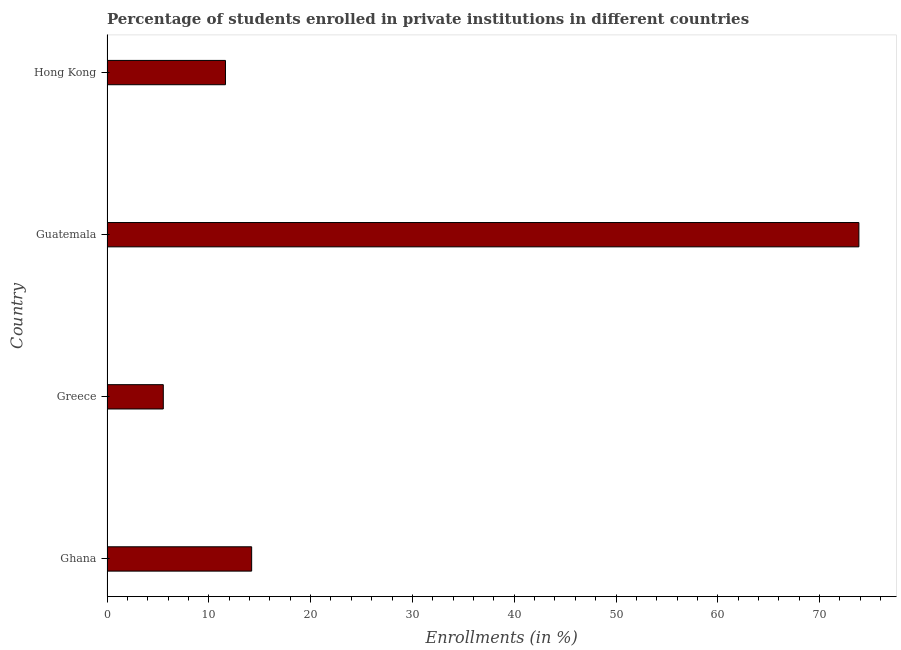Does the graph contain any zero values?
Your answer should be very brief. No. What is the title of the graph?
Your response must be concise. Percentage of students enrolled in private institutions in different countries. What is the label or title of the X-axis?
Ensure brevity in your answer.  Enrollments (in %). What is the label or title of the Y-axis?
Ensure brevity in your answer.  Country. What is the enrollments in private institutions in Greece?
Offer a terse response. 5.53. Across all countries, what is the maximum enrollments in private institutions?
Your answer should be very brief. 73.86. Across all countries, what is the minimum enrollments in private institutions?
Keep it short and to the point. 5.53. In which country was the enrollments in private institutions maximum?
Offer a very short reply. Guatemala. In which country was the enrollments in private institutions minimum?
Your answer should be very brief. Greece. What is the sum of the enrollments in private institutions?
Your answer should be compact. 105.24. What is the difference between the enrollments in private institutions in Greece and Guatemala?
Give a very brief answer. -68.33. What is the average enrollments in private institutions per country?
Keep it short and to the point. 26.31. What is the median enrollments in private institutions?
Keep it short and to the point. 12.92. In how many countries, is the enrollments in private institutions greater than 36 %?
Your answer should be very brief. 1. What is the ratio of the enrollments in private institutions in Ghana to that in Greece?
Provide a succinct answer. 2.57. What is the difference between the highest and the second highest enrollments in private institutions?
Ensure brevity in your answer.  59.65. What is the difference between the highest and the lowest enrollments in private institutions?
Provide a succinct answer. 68.33. In how many countries, is the enrollments in private institutions greater than the average enrollments in private institutions taken over all countries?
Keep it short and to the point. 1. Are all the bars in the graph horizontal?
Provide a succinct answer. Yes. Are the values on the major ticks of X-axis written in scientific E-notation?
Make the answer very short. No. What is the Enrollments (in %) of Ghana?
Offer a very short reply. 14.21. What is the Enrollments (in %) in Greece?
Offer a terse response. 5.53. What is the Enrollments (in %) of Guatemala?
Provide a succinct answer. 73.86. What is the Enrollments (in %) in Hong Kong?
Ensure brevity in your answer.  11.64. What is the difference between the Enrollments (in %) in Ghana and Greece?
Provide a succinct answer. 8.68. What is the difference between the Enrollments (in %) in Ghana and Guatemala?
Your answer should be compact. -59.65. What is the difference between the Enrollments (in %) in Ghana and Hong Kong?
Your response must be concise. 2.57. What is the difference between the Enrollments (in %) in Greece and Guatemala?
Give a very brief answer. -68.33. What is the difference between the Enrollments (in %) in Greece and Hong Kong?
Ensure brevity in your answer.  -6.11. What is the difference between the Enrollments (in %) in Guatemala and Hong Kong?
Your answer should be very brief. 62.22. What is the ratio of the Enrollments (in %) in Ghana to that in Greece?
Offer a very short reply. 2.57. What is the ratio of the Enrollments (in %) in Ghana to that in Guatemala?
Provide a succinct answer. 0.19. What is the ratio of the Enrollments (in %) in Ghana to that in Hong Kong?
Offer a terse response. 1.22. What is the ratio of the Enrollments (in %) in Greece to that in Guatemala?
Keep it short and to the point. 0.07. What is the ratio of the Enrollments (in %) in Greece to that in Hong Kong?
Offer a terse response. 0.47. What is the ratio of the Enrollments (in %) in Guatemala to that in Hong Kong?
Your answer should be very brief. 6.35. 